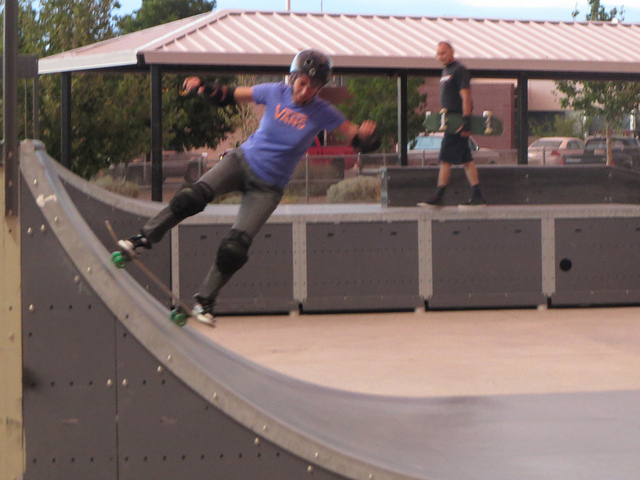What is happening in this image? A skateboarder is performing a trick on a ramp while wearing protective gear and a blue Vans t-shirt. There is another person in the background observing the practice. Can you describe the environment around the skateboarder? The environment is an outdoor skate park with a covered seating area or pavilion in the background. There are trees around and parked vehicles can be seen in the background, suggesting this is a park area. Overall, it seems like a dedicated spot for skating enthusiasts to hone their skills. Imagine the skateboarder is training for a big competition. What challenges might they be facing? The skateboarder, training for a big competition, might be facing several challenges such as mastering new tricks, maintaining balance, and perfecting their technique. They need to focus on consistency and precision to deliver flawless performances. Physical endurance and mental composure are crucial during high-stress moments. Additionally, weather conditions and the condition of the equipment could also pose challenges. 